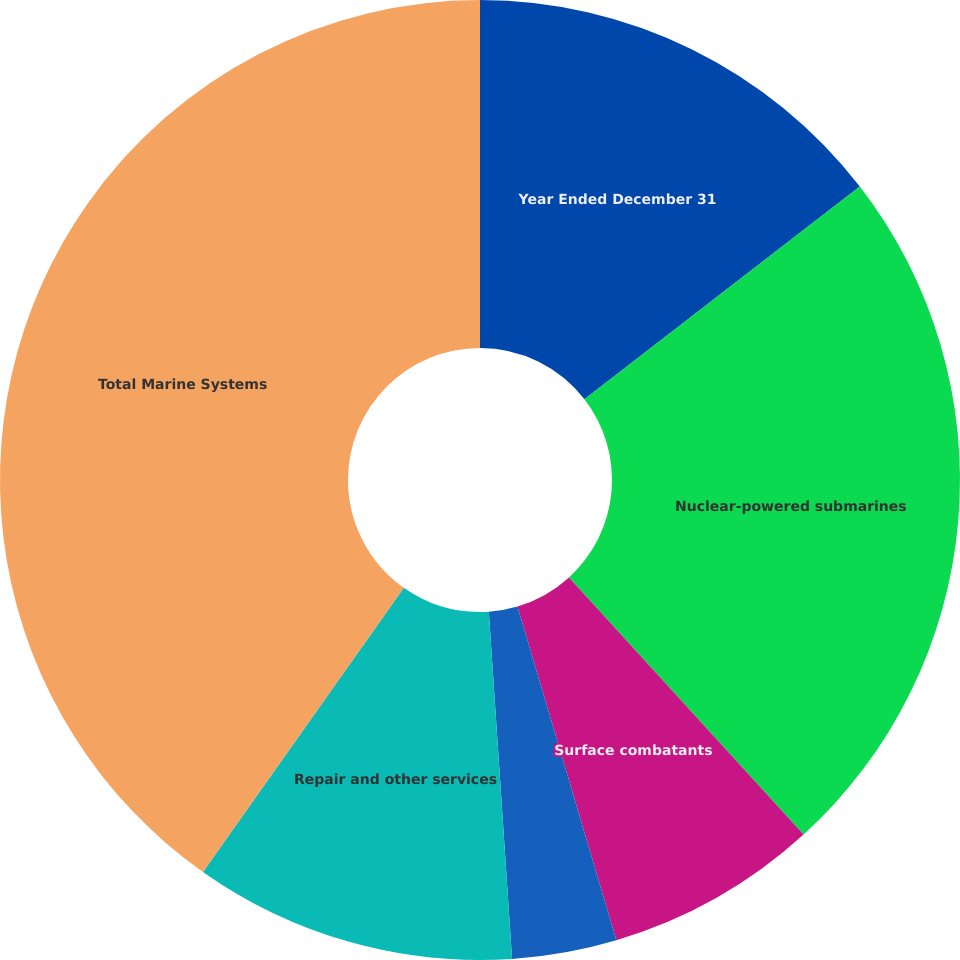Convert chart. <chart><loc_0><loc_0><loc_500><loc_500><pie_chart><fcel>Year Ended December 31<fcel>Nuclear-powered submarines<fcel>Surface combatants<fcel>Auxiliary and commercial ships<fcel>Repair and other services<fcel>Total Marine Systems<nl><fcel>14.53%<fcel>23.7%<fcel>7.19%<fcel>3.52%<fcel>10.86%<fcel>40.21%<nl></chart> 